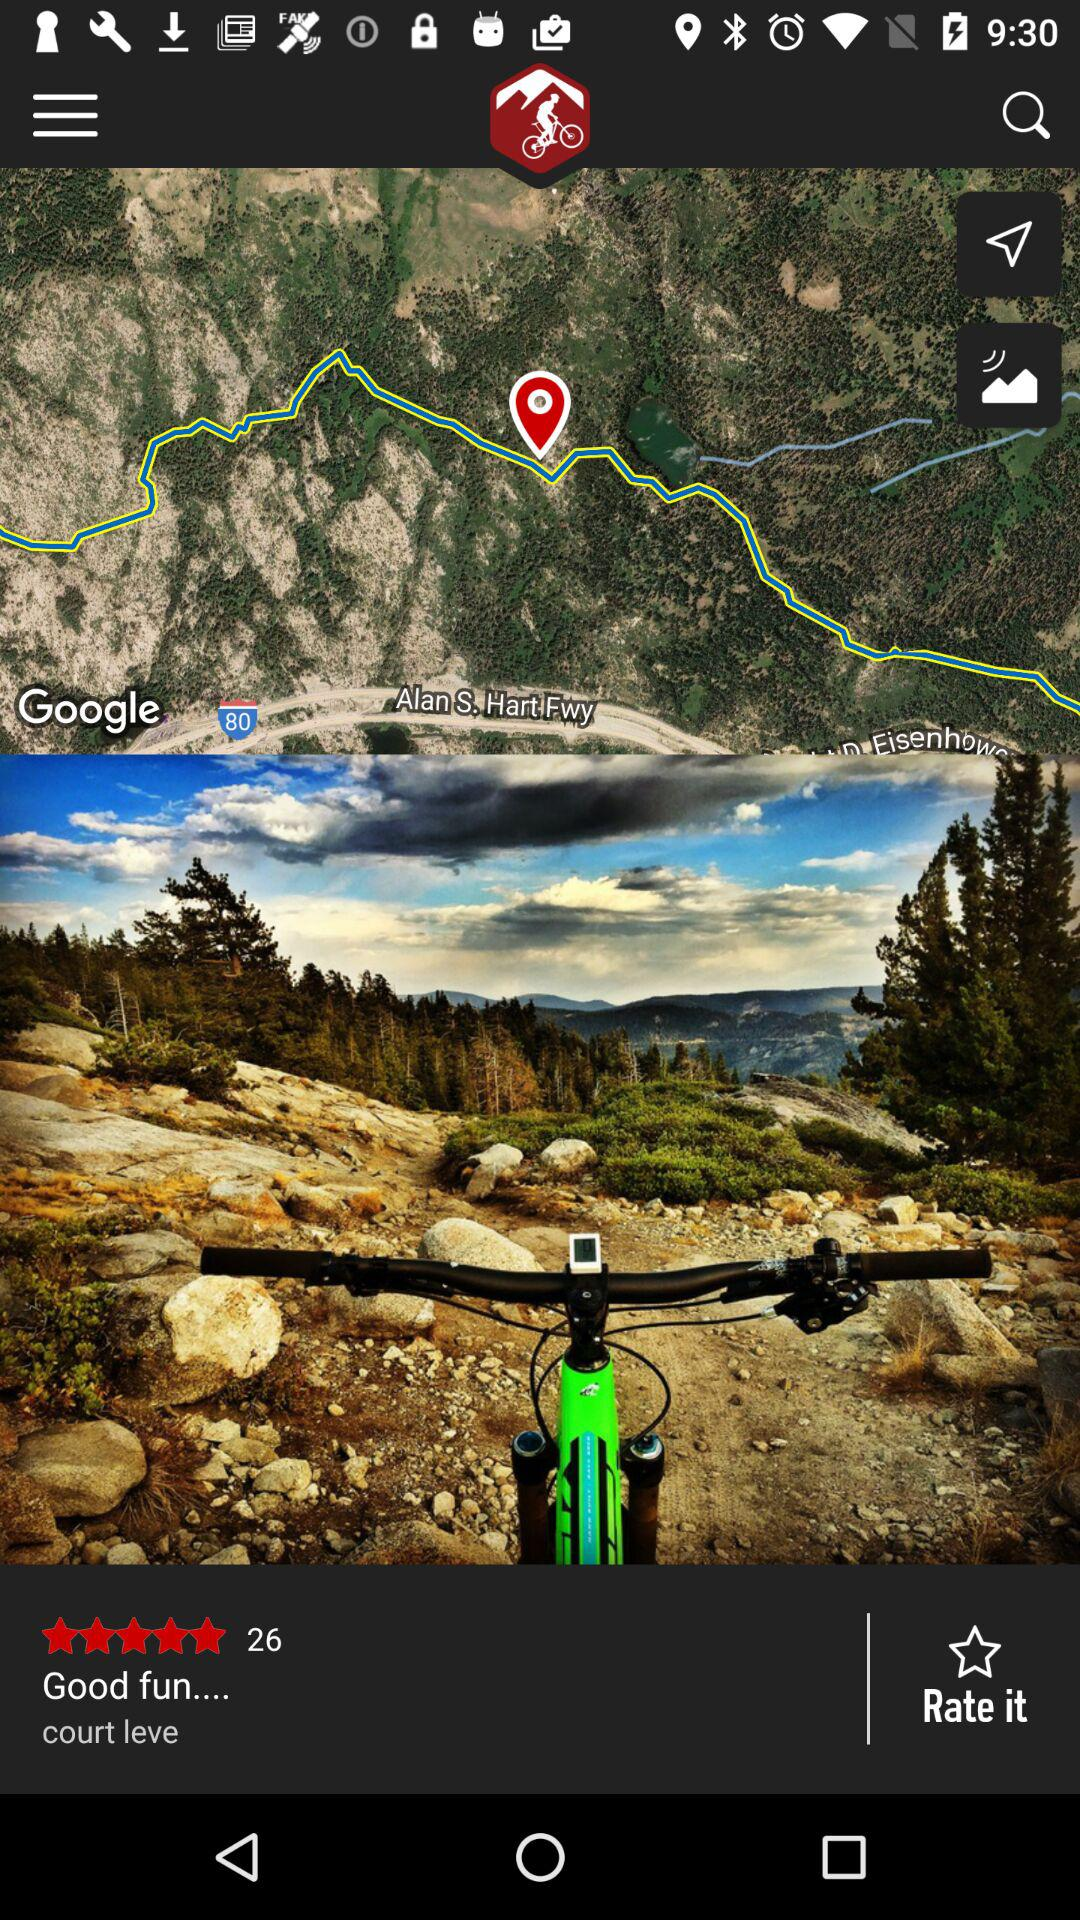What is the rating? The rating is 5 stars. 